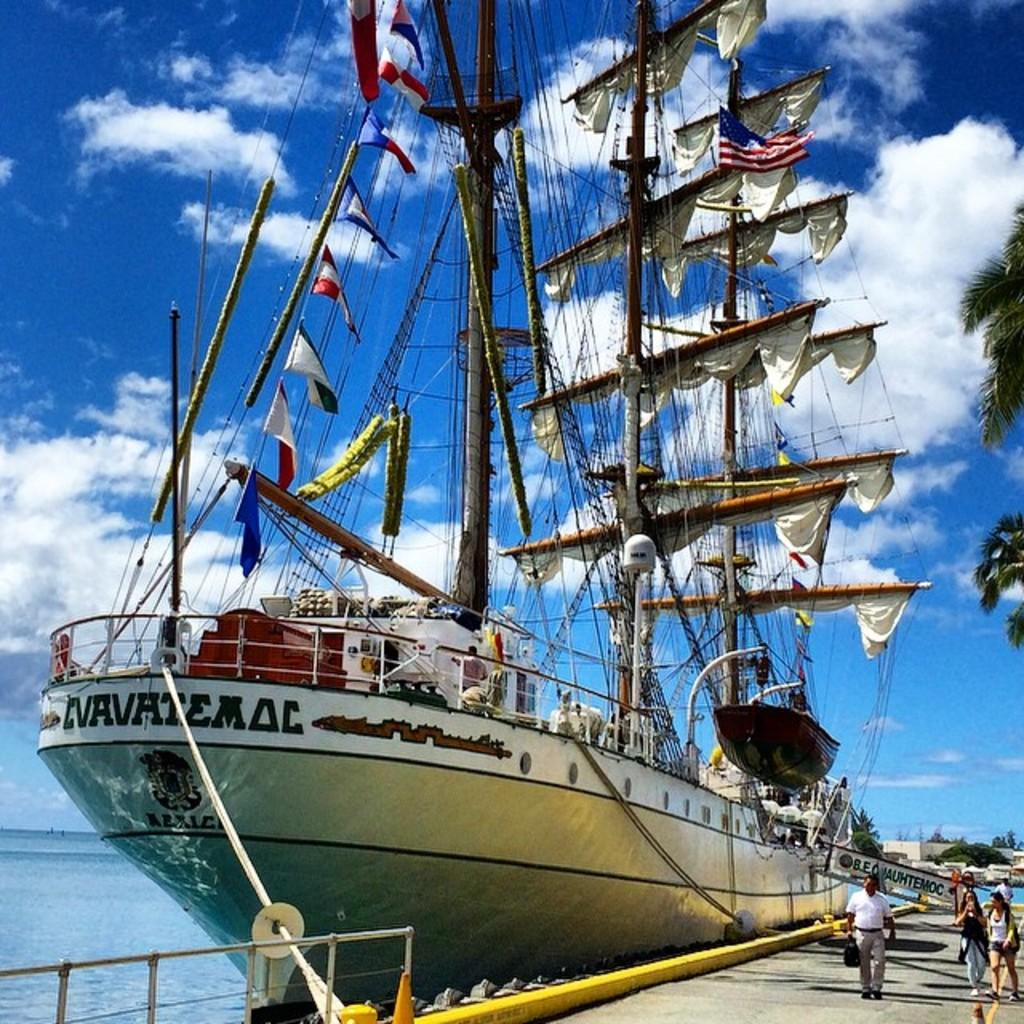What is the main subject in the center of the image? There is a ship in the center of the image. Where is the ship located? The ship is on the water. What can be seen at the bottom of the image? There is a railing at the bottom of the image. Who or what can be seen on the right side of the image? There are people visible on the right side of the image. What is visible in the background of the image? There are trees and the sky in the background of the image. How many deer are visible in the image? There are no deer present in the image. What type of army is depicted in the image? There is no army depicted in the image; it features a ship on the water with people and a railing. 